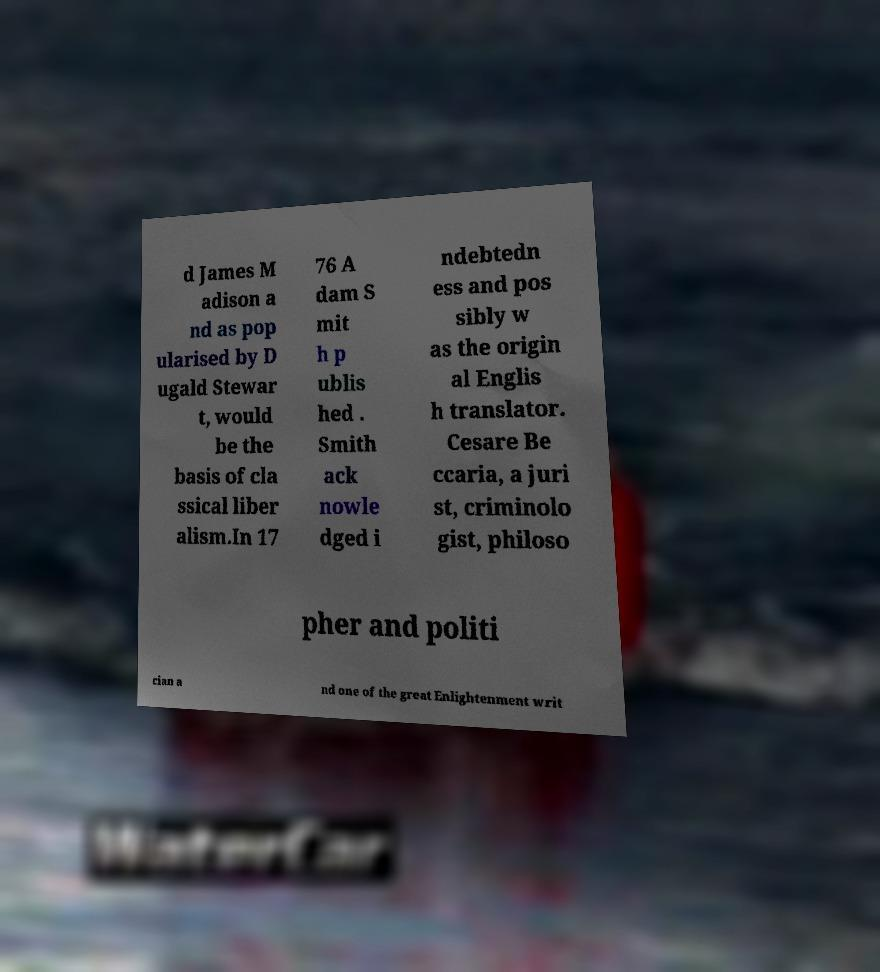Could you extract and type out the text from this image? d James M adison a nd as pop ularised by D ugald Stewar t, would be the basis of cla ssical liber alism.In 17 76 A dam S mit h p ublis hed . Smith ack nowle dged i ndebtedn ess and pos sibly w as the origin al Englis h translator. Cesare Be ccaria, a juri st, criminolo gist, philoso pher and politi cian a nd one of the great Enlightenment writ 